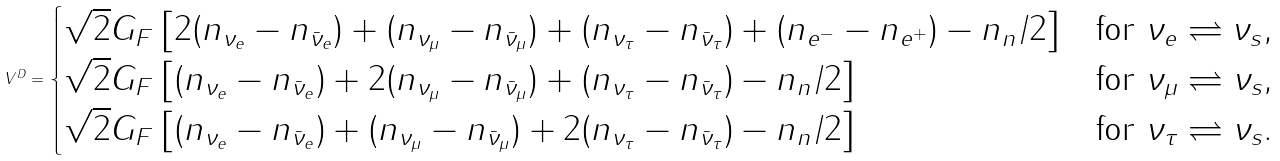Convert formula to latex. <formula><loc_0><loc_0><loc_500><loc_500>V ^ { D } = \begin{cases} \sqrt { 2 } G _ { F } \left [ 2 ( n _ { \nu _ { e } } - n _ { \bar { \nu } _ { e } } ) + ( n _ { \nu _ { \mu } } - n _ { \bar { \nu } _ { \mu } } ) + ( n _ { \nu _ { \tau } } - n _ { \bar { \nu } _ { \tau } } ) + ( n _ { e ^ { - } } - n _ { e ^ { + } } ) - n _ { n } / 2 \right ] & \text {for\ } \nu _ { e } \rightleftharpoons \nu _ { s } , \\ \sqrt { 2 } G _ { F } \left [ ( n _ { \nu _ { e } } - n _ { \bar { \nu } _ { e } } ) + 2 ( n _ { \nu _ { \mu } } - n _ { \bar { \nu } _ { \mu } } ) + ( n _ { \nu _ { \tau } } - n _ { \bar { \nu } _ { \tau } } ) - n _ { n } / 2 \right ] & \text {for\ } \nu _ { \mu } \rightleftharpoons \nu _ { s } , \\ \sqrt { 2 } G _ { F } \left [ ( n _ { \nu _ { e } } - n _ { \bar { \nu } _ { e } } ) + ( n _ { \nu _ { \mu } } - n _ { \bar { \nu } _ { \mu } } ) + 2 ( n _ { \nu _ { \tau } } - n _ { \bar { \nu } _ { \tau } } ) - n _ { n } / 2 \right ] & \text {for\ } \nu _ { \tau } \rightleftharpoons \nu _ { s } . \end{cases}</formula> 